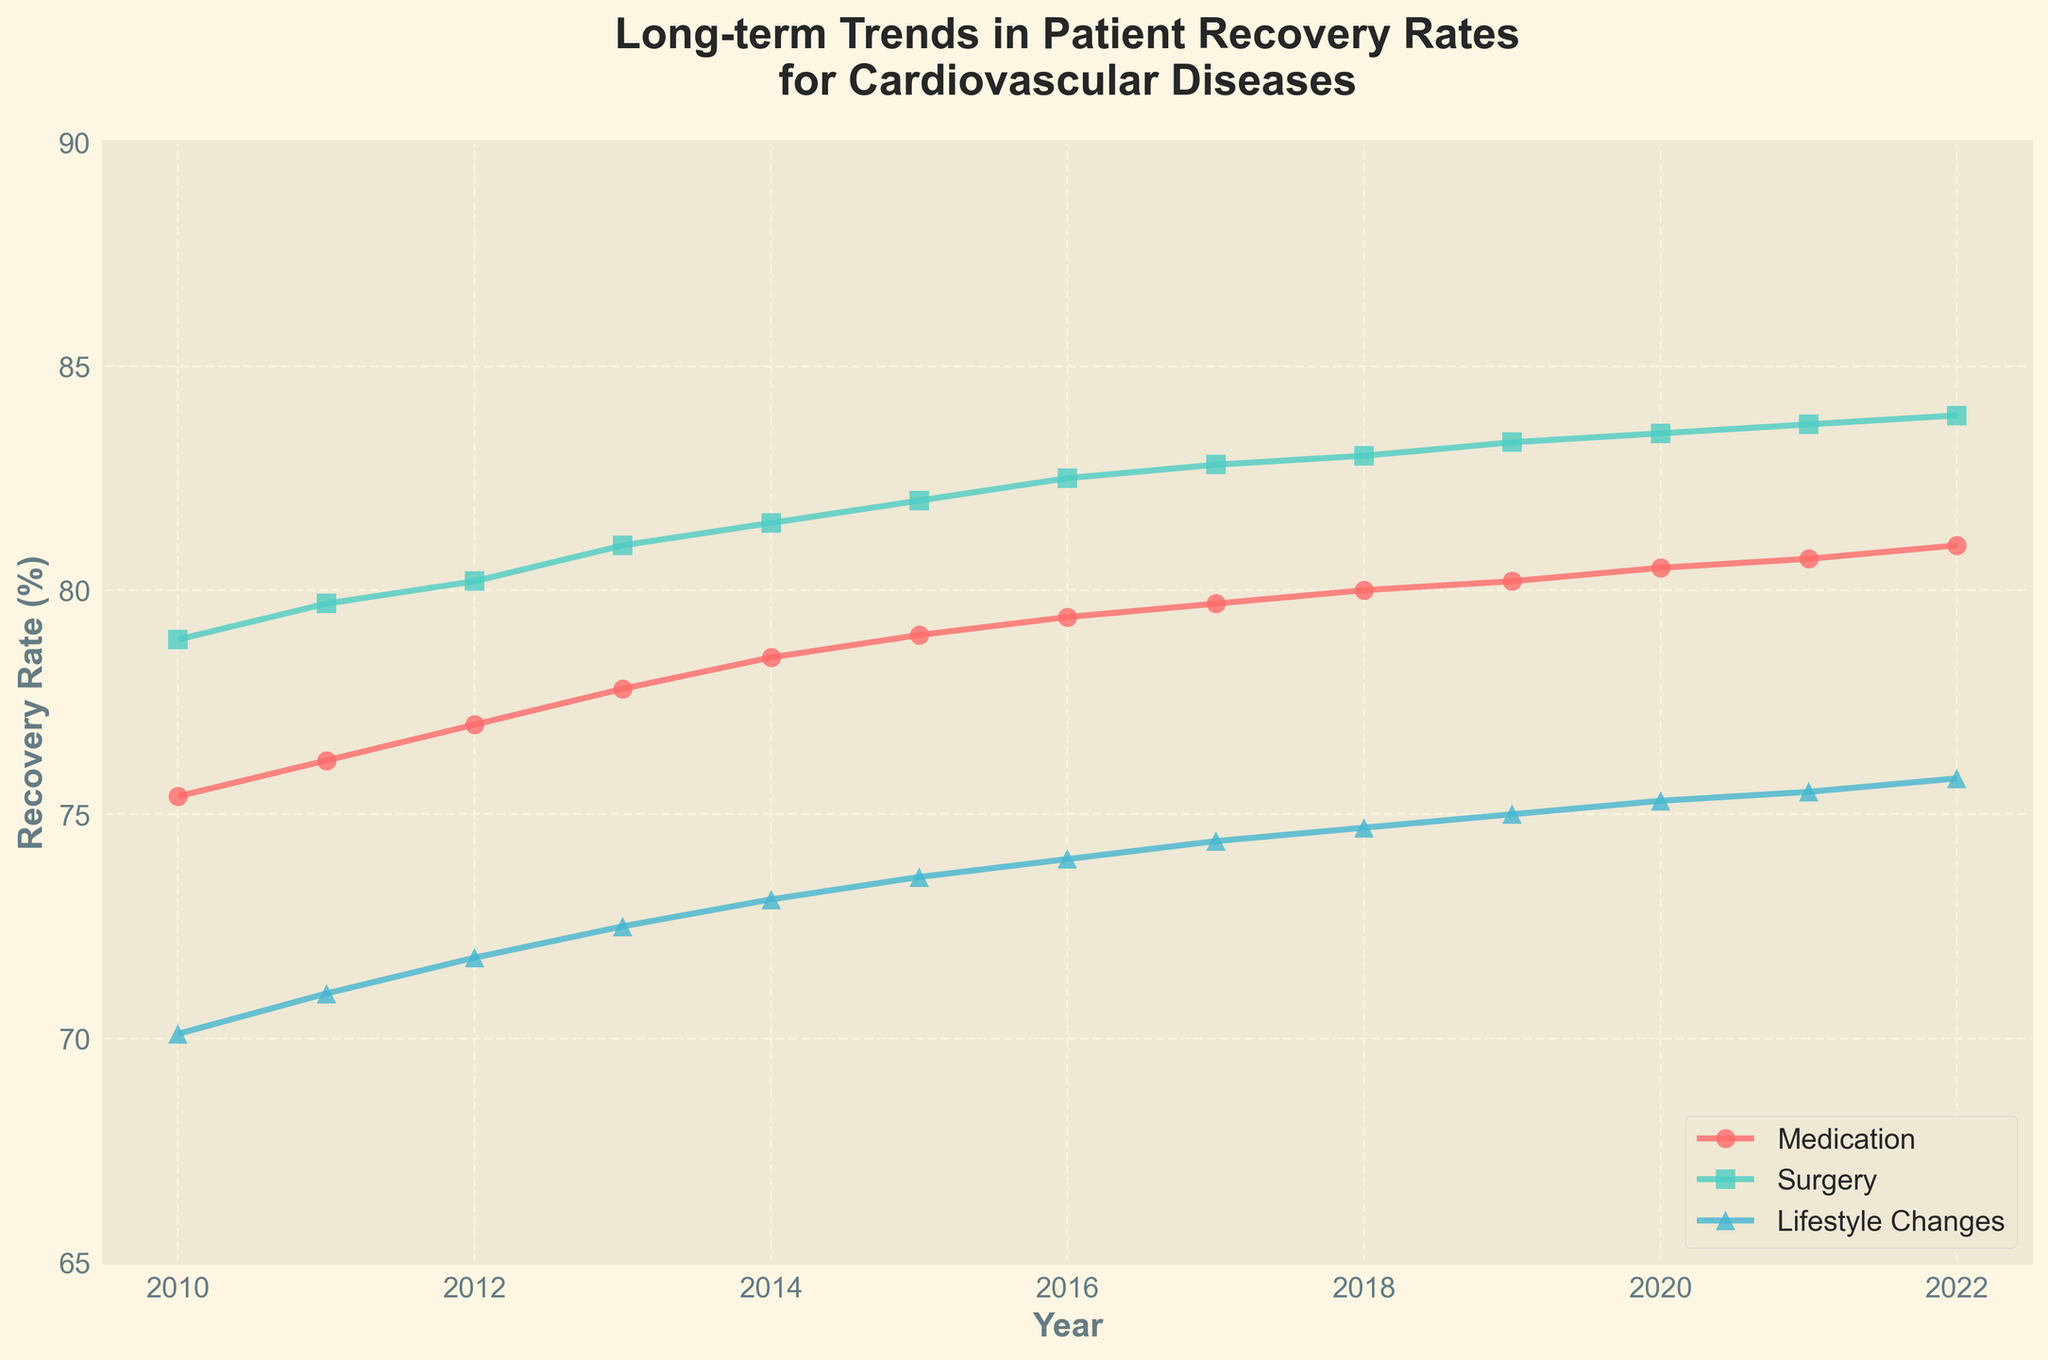What's the title of the figure? The title is displayed prominently at the top of the figure. It is “Long-term Trends in Patient Recovery Rates for Cardiovascular Diseases."
Answer: Long-term Trends in Patient Recovery Rates for Cardiovascular Diseases What is the recovery rate for lifestyle changes in 2020? Locate the data point corresponding to 2020 on the x-axis for the 'Lifestyle Changes' treatment line, which is indicated with a specific color and marker shape. The y-axis shows a recovery rate of approximately 75.3%.
Answer: 75.3% How does the recovery rate for surgery compare between 2010 and 2022? The figure shows the line for surgery with specific markers. The recovery rate for surgery in 2010 was approximately 78.9%, and in 2022 it was about 83.9%. The recovery rate for surgery increased by 5 percentage points over this period.
Answer: Increased by 5% Which treatment type had the highest recovery rate in 2015? Observe the data points for 2015 across all treatment types. The surgery line shows the highest recovery rate of 82.0% for that year.
Answer: Surgery Calculate the average recovery rate for medication from 2010 to 2022. Add the annual recovery rates for medication from 2010 to 2022 (75.4, 76.2, 77.0, 77.8, 78.5, 79.0, 79.4, 79.7, 80.0, 80.2, 80.5, 80.7, 81.0), which totals 946.4. Then divide by the number of years (13), resulting in an average recovery rate of approximately 72.8%.
Answer: 72.8% Between which years did the recovery rate for lifestyle changes see the largest increase? Compare the year-to-year increments by closely observing the points on the lifestyle changes line. The largest increase is observed between 2016 (74.0%) and 2017 (74.4%), which is an increase of 0.4%.
Answer: 2016 to 2017 What is the overall trend in recovery rates for all treatments from 2010 to 2022? Observe the general direction of the lines for all treatments over the years. All treatment types consistently show an increasing trend in recovery rates from 2010 to 2022.
Answer: Increasing trend Which year saw the smallest increase in recovery rate for medication compared to the previous year? Analyze the year-over-year changes for medication, looking at the differences in recovery rates. The year 2010 to 2011 saw the smallest increase, from 75.4% to 76.2%, an increase of just 0.8%.
Answer: 2010 to 2011 